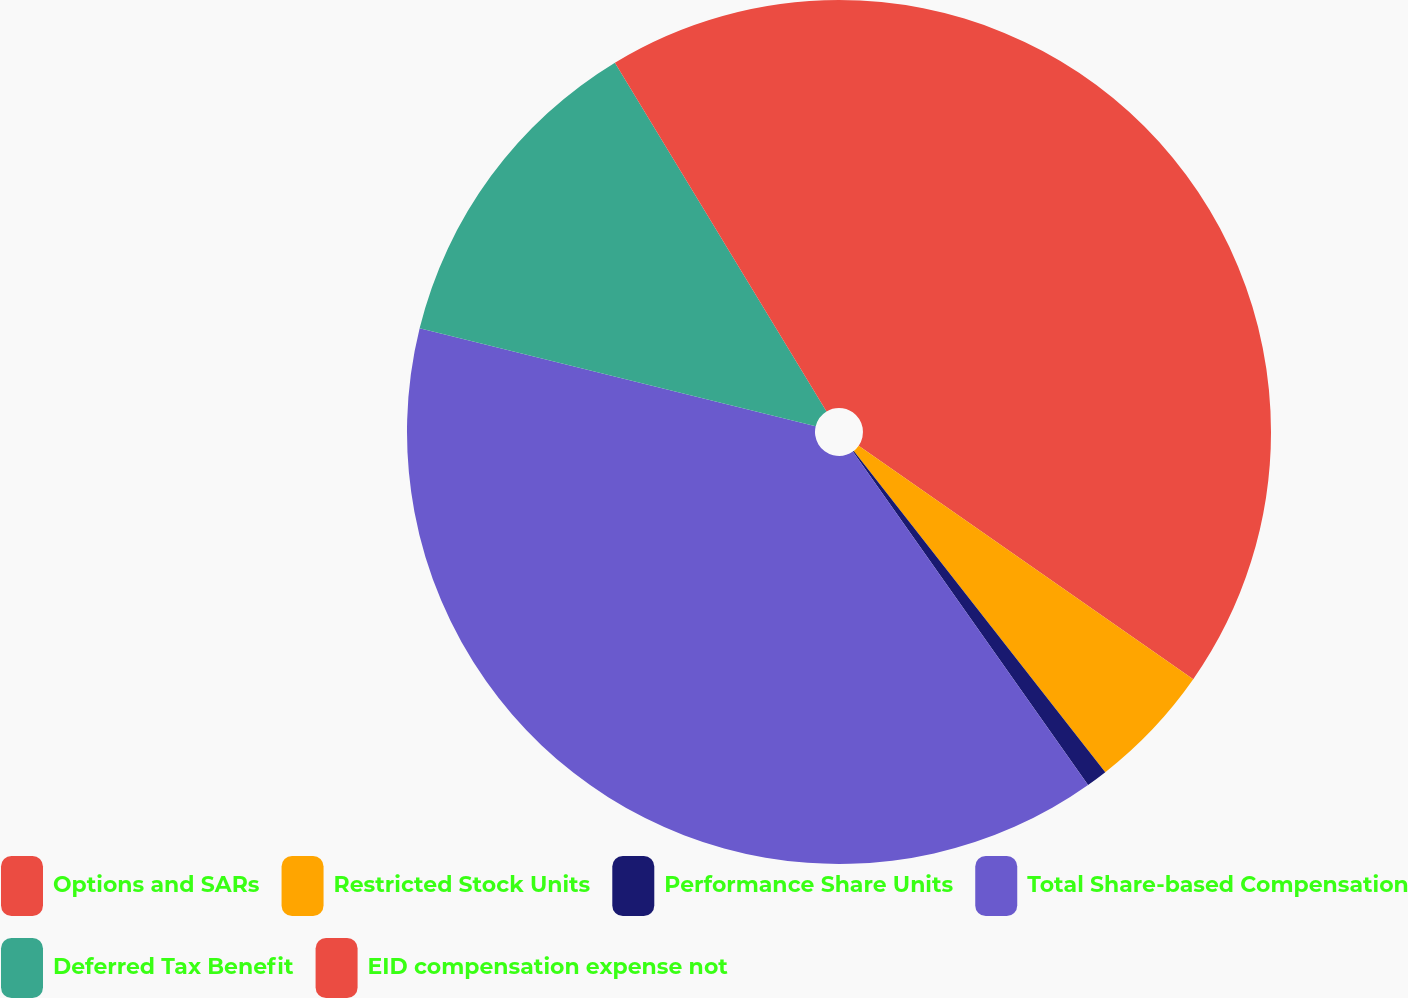<chart> <loc_0><loc_0><loc_500><loc_500><pie_chart><fcel>Options and SARs<fcel>Restricted Stock Units<fcel>Performance Share Units<fcel>Total Share-based Compensation<fcel>Deferred Tax Benefit<fcel>EID compensation expense not<nl><fcel>34.7%<fcel>4.73%<fcel>0.79%<fcel>38.64%<fcel>12.46%<fcel>8.68%<nl></chart> 